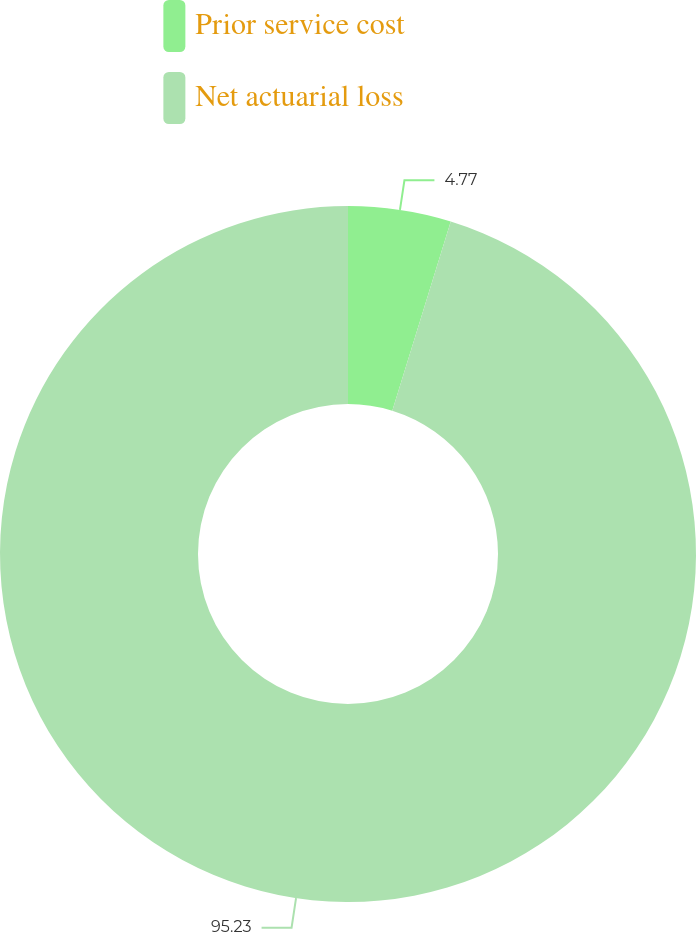Convert chart to OTSL. <chart><loc_0><loc_0><loc_500><loc_500><pie_chart><fcel>Prior service cost<fcel>Net actuarial loss<nl><fcel>4.77%<fcel>95.23%<nl></chart> 